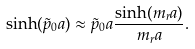<formula> <loc_0><loc_0><loc_500><loc_500>\sinh ( \tilde { p } _ { 0 } a ) \approx \tilde { p } _ { 0 } a \frac { \sinh ( m _ { r } a ) } { m _ { r } a } .</formula> 